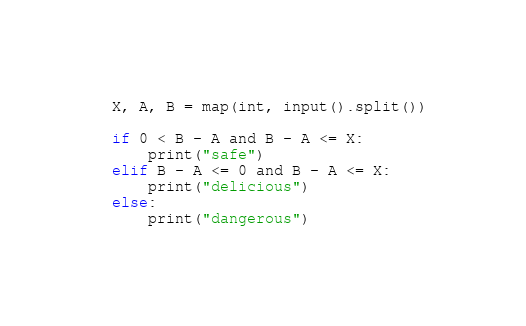Convert code to text. <code><loc_0><loc_0><loc_500><loc_500><_Python_>X, A, B = map(int, input().split())

if 0 < B - A and B - A <= X:
    print("safe")
elif B - A <= 0 and B - A <= X:
    print("delicious")
else:
    print("dangerous")</code> 